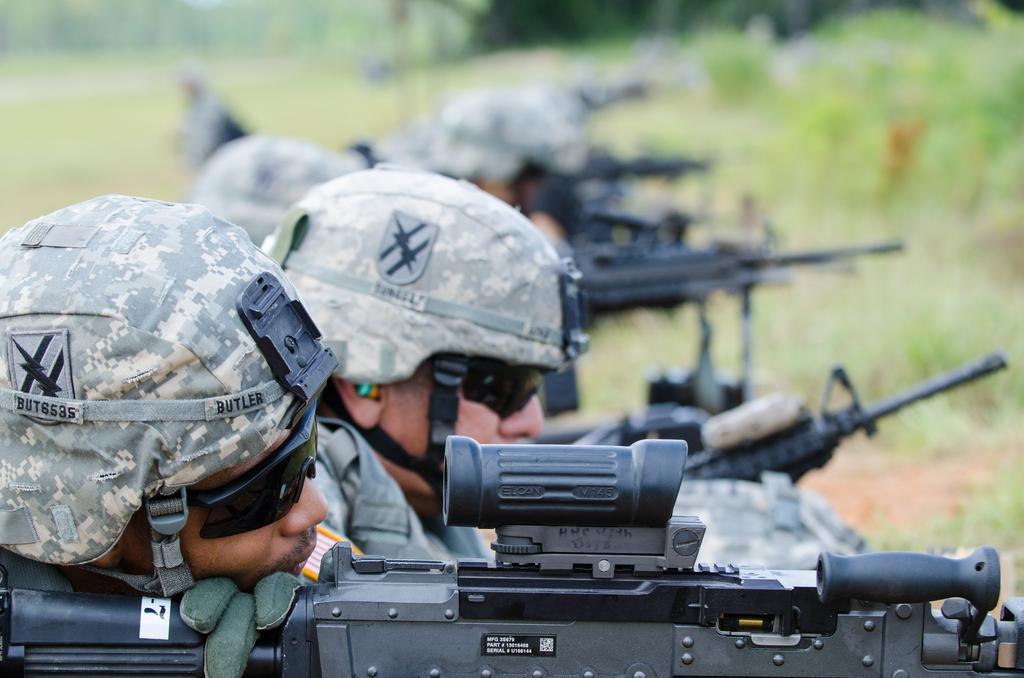Describe this image in one or two sentences. On the left side of the image we can see some people are wearing the uniforms, caps, glasses and holding the guns. In the background of the image we can see the plants and trees. 